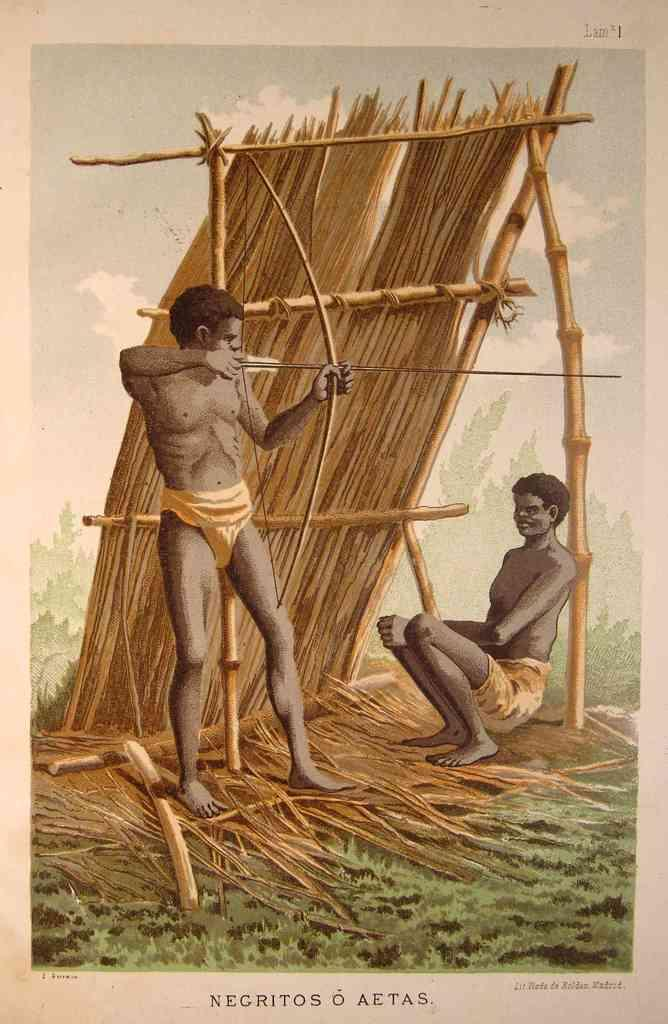What type of artwork is shown in the image? The image is a painting. What is happening in the painting? There are persons depicted in the painting. What objects can be seen in the painting? There are wooden sticks and grass depicted in the painting. What is the background of the painting? There is sky and clouds depicted in the painting. What time is shown on the clock in the painting? There is no clock present in the painting. What type of tail can be seen on the animal in the painting? There are no animals depicted in the painting, and therefore no tails can be seen. 